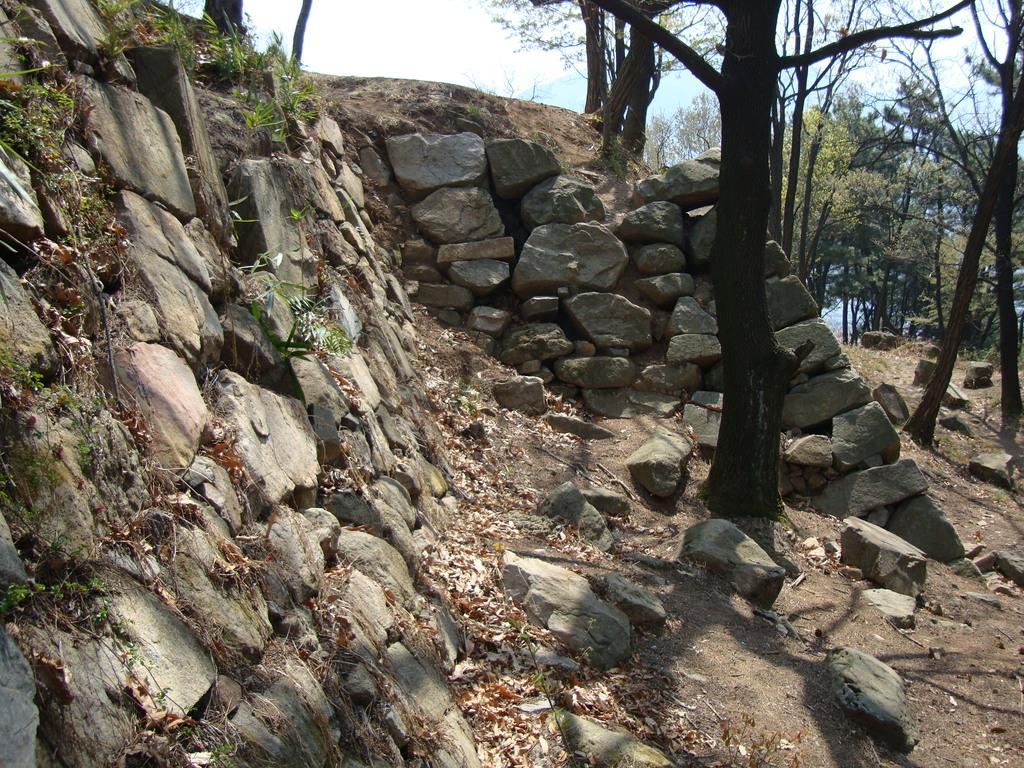What type of natural elements can be seen in the image? There are stones, grass, and trees visible in the image. What additional objects can be found in the image? Dry leaves are present in the image. What is visible in the background of the image? The sky is visible in the background of the image. What type of thread is being used to create the account in the image? There is no thread or account present in the image; it features natural elements such as stones, grass, dry leaves, trees, and the sky. 